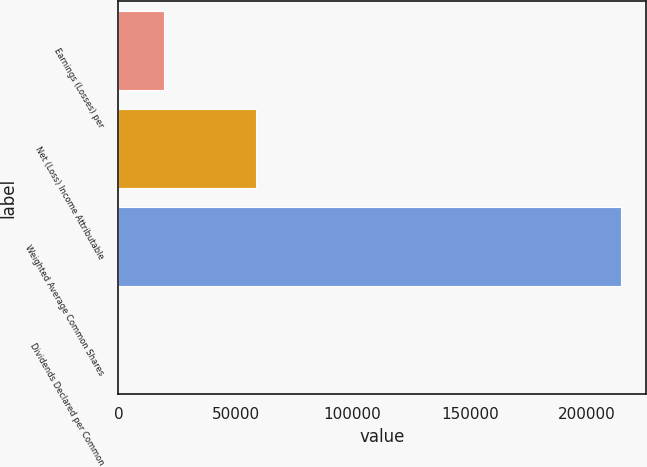<chart> <loc_0><loc_0><loc_500><loc_500><bar_chart><fcel>Earnings (Losses) per<fcel>Net (Loss) Income Attributable<fcel>Weighted Average Common Shares<fcel>Dividends Declared per Common<nl><fcel>19594.7<fcel>58782.1<fcel>214371<fcel>0.94<nl></chart> 